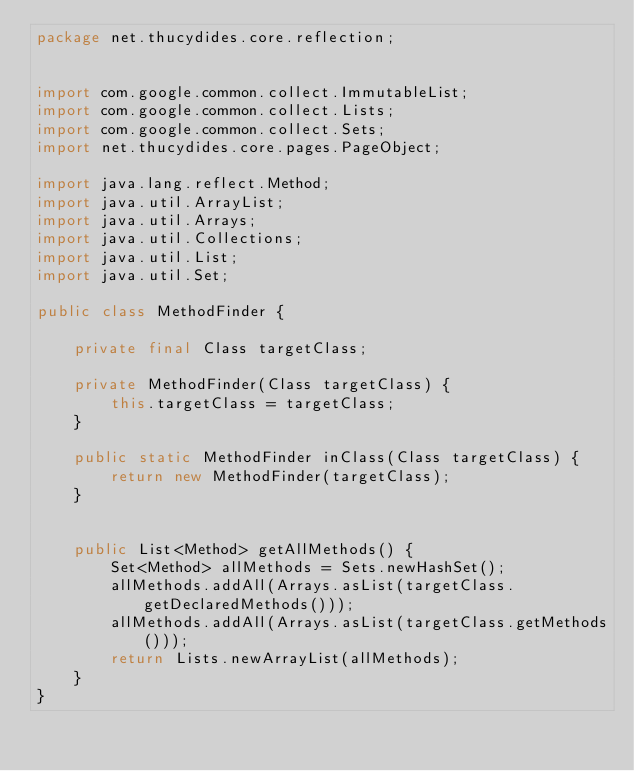Convert code to text. <code><loc_0><loc_0><loc_500><loc_500><_Java_>package net.thucydides.core.reflection;


import com.google.common.collect.ImmutableList;
import com.google.common.collect.Lists;
import com.google.common.collect.Sets;
import net.thucydides.core.pages.PageObject;

import java.lang.reflect.Method;
import java.util.ArrayList;
import java.util.Arrays;
import java.util.Collections;
import java.util.List;
import java.util.Set;

public class MethodFinder {

    private final Class targetClass;

    private MethodFinder(Class targetClass) {
        this.targetClass = targetClass;
    }

    public static MethodFinder inClass(Class targetClass) {
        return new MethodFinder(targetClass);
    }


    public List<Method> getAllMethods() {
        Set<Method> allMethods = Sets.newHashSet();
        allMethods.addAll(Arrays.asList(targetClass.getDeclaredMethods()));
        allMethods.addAll(Arrays.asList(targetClass.getMethods()));
        return Lists.newArrayList(allMethods);
    }
}
</code> 